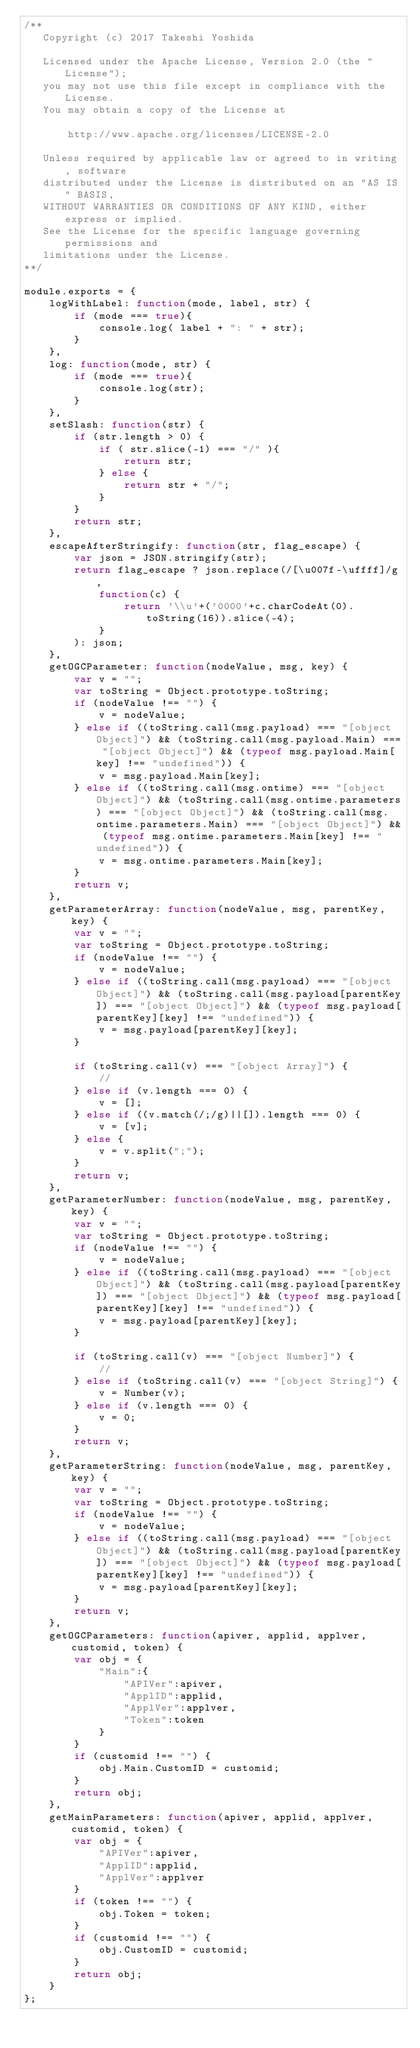Convert code to text. <code><loc_0><loc_0><loc_500><loc_500><_JavaScript_>/**
   Copyright (c) 2017 Takeshi Yoshida

   Licensed under the Apache License, Version 2.0 (the "License");
   you may not use this file except in compliance with the License.
   You may obtain a copy of the License at

       http://www.apache.org/licenses/LICENSE-2.0

   Unless required by applicable law or agreed to in writing, software
   distributed under the License is distributed on an "AS IS" BASIS,
   WITHOUT WARRANTIES OR CONDITIONS OF ANY KIND, either express or implied.
   See the License for the specific language governing permissions and
   limitations under the License.
**/

module.exports = {
    logWithLabel: function(mode, label, str) {
    	if (mode === true){
			console.log( label + ": " + str);
	    }
	},
    log: function(mode, str) {
    	if (mode === true){
			console.log(str);
	    }
	},
    setSlash: function(str) {
    	if (str.length > 0) {
    		if ( str.slice(-1) === "/" ){
    			return str;
    		} else {
    			return str + "/";
    		}
    	}
    	return str;
	},
	escapeAfterStringify: function(str, flag_escape) {
		var json = JSON.stringify(str);
	   	return flag_escape ? json.replace(/[\u007f-\uffff]/g,
			function(c) { 
				return '\\u'+('0000'+c.charCodeAt(0).toString(16)).slice(-4);
		  	}
	   	): json;
	},
	getOGCParameter: function(nodeValue, msg, key) {
		var v = "";
		var toString = Object.prototype.toString;
		if (nodeValue !== "") {
			v = nodeValue;
		} else if ((toString.call(msg.payload) === "[object Object]") && (toString.call(msg.payload.Main) === "[object Object]") && (typeof msg.payload.Main[key] !== "undefined")) {
			v = msg.payload.Main[key];
		} else if ((toString.call(msg.ontime) === "[object Object]") && (toString.call(msg.ontime.parameters) === "[object Object]") && (toString.call(msg.ontime.parameters.Main) === "[object Object]") && (typeof msg.ontime.parameters.Main[key] !== "undefined")) {
			v = msg.ontime.parameters.Main[key];
		}
		return v;
	},
	getParameterArray: function(nodeValue, msg, parentKey, key) {
		var v = "";
		var toString = Object.prototype.toString;
		if (nodeValue !== "") {
			v = nodeValue;
		} else if ((toString.call(msg.payload) === "[object Object]") && (toString.call(msg.payload[parentKey]) === "[object Object]") && (typeof msg.payload[parentKey][key] !== "undefined")) {
			v = msg.payload[parentKey][key];
		}

		if (toString.call(v) === "[object Array]") {
			//
		} else if (v.length === 0) {
			v = [];
		} else if ((v.match(/;/g)||[]).length === 0) {
		 	v = [v];
		} else {
		 	v = v.split(";");
		}
		return v;
	},
	getParameterNumber: function(nodeValue, msg, parentKey, key) {
		var v = "";
		var toString = Object.prototype.toString;
		if (nodeValue !== "") {
			v = nodeValue;
		} else if ((toString.call(msg.payload) === "[object Object]") && (toString.call(msg.payload[parentKey]) === "[object Object]") && (typeof msg.payload[parentKey][key] !== "undefined")) {
			v = msg.payload[parentKey][key];
		}

		if (toString.call(v) === "[object Number]") {
			//
		} else if (toString.call(v) === "[object String]") {
			v = Number(v);
		} else if (v.length === 0) {
			v = 0;
		}
		return v;
	},
	getParameterString: function(nodeValue, msg, parentKey, key) {
		var v = "";
		var toString = Object.prototype.toString;
		if (nodeValue !== "") {
			v = nodeValue;
		} else if ((toString.call(msg.payload) === "[object Object]") && (toString.call(msg.payload[parentKey]) === "[object Object]") && (typeof msg.payload[parentKey][key] !== "undefined")) {
			v = msg.payload[parentKey][key];
		}
		return v;
	},
	getOGCParameters: function(apiver, applid, applver, customid, token) {
		var obj = {
			"Main":{
				"APIVer":apiver,
				"ApplID":applid,
				"ApplVer":applver,
				"Token":token
			}
		}
		if (customid !== "") {
			obj.Main.CustomID = customid;
		}
		return obj;
	},
	getMainParameters: function(apiver, applid, applver, customid, token) {
		var obj = {
			"APIVer":apiver,
			"ApplID":applid,
			"ApplVer":applver
		}
		if (token !== "") {
			obj.Token = token;
		}
		if (customid !== "") {
			obj.CustomID = customid;
		}
		return obj;
	}
};</code> 